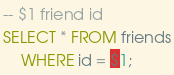<code> <loc_0><loc_0><loc_500><loc_500><_SQL_>-- $1 friend id
SELECT * FROM friends
	WHERE id = $1;</code> 